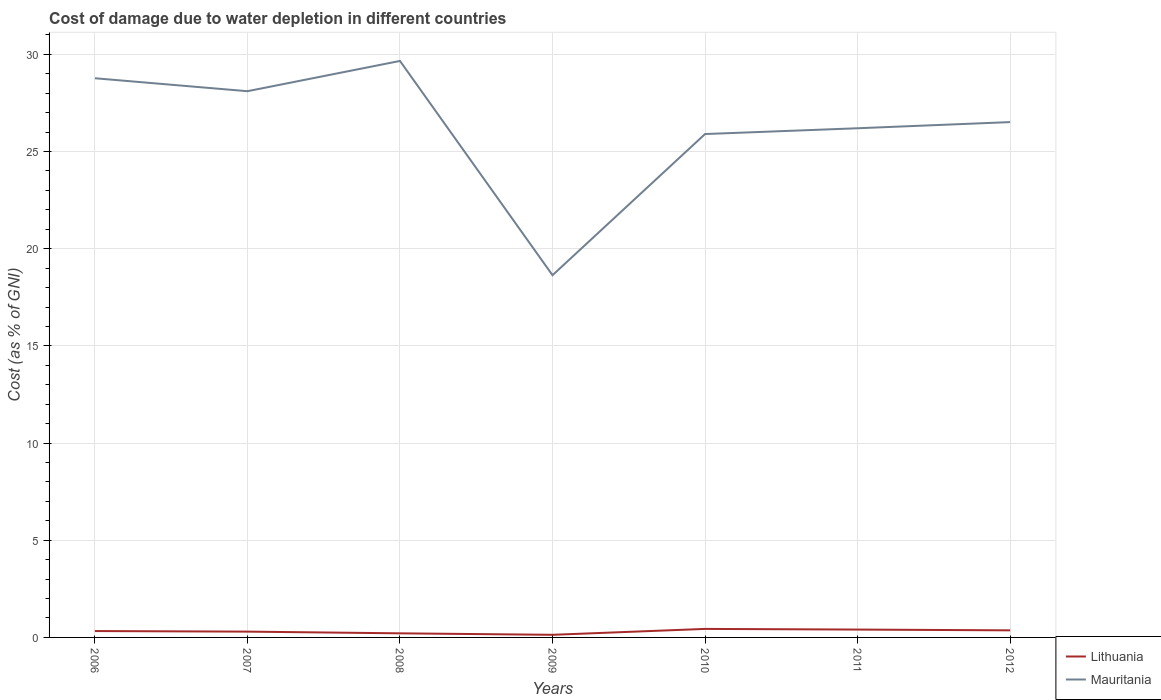How many different coloured lines are there?
Your answer should be compact. 2. Across all years, what is the maximum cost of damage caused due to water depletion in Lithuania?
Keep it short and to the point. 0.13. What is the total cost of damage caused due to water depletion in Mauritania in the graph?
Offer a very short reply. 3.46. What is the difference between the highest and the second highest cost of damage caused due to water depletion in Lithuania?
Provide a short and direct response. 0.3. Is the cost of damage caused due to water depletion in Lithuania strictly greater than the cost of damage caused due to water depletion in Mauritania over the years?
Offer a very short reply. Yes. How many lines are there?
Your answer should be compact. 2. What is the difference between two consecutive major ticks on the Y-axis?
Keep it short and to the point. 5. Are the values on the major ticks of Y-axis written in scientific E-notation?
Offer a terse response. No. Does the graph contain grids?
Your answer should be compact. Yes. Where does the legend appear in the graph?
Your answer should be compact. Bottom right. What is the title of the graph?
Make the answer very short. Cost of damage due to water depletion in different countries. What is the label or title of the Y-axis?
Give a very brief answer. Cost (as % of GNI). What is the Cost (as % of GNI) in Lithuania in 2006?
Offer a very short reply. 0.33. What is the Cost (as % of GNI) in Mauritania in 2006?
Give a very brief answer. 28.77. What is the Cost (as % of GNI) of Lithuania in 2007?
Provide a short and direct response. 0.3. What is the Cost (as % of GNI) of Mauritania in 2007?
Keep it short and to the point. 28.1. What is the Cost (as % of GNI) of Lithuania in 2008?
Offer a terse response. 0.21. What is the Cost (as % of GNI) in Mauritania in 2008?
Offer a terse response. 29.66. What is the Cost (as % of GNI) of Lithuania in 2009?
Your answer should be compact. 0.13. What is the Cost (as % of GNI) of Mauritania in 2009?
Provide a short and direct response. 18.64. What is the Cost (as % of GNI) of Lithuania in 2010?
Provide a succinct answer. 0.44. What is the Cost (as % of GNI) in Mauritania in 2010?
Your answer should be very brief. 25.9. What is the Cost (as % of GNI) of Lithuania in 2011?
Your response must be concise. 0.4. What is the Cost (as % of GNI) of Mauritania in 2011?
Give a very brief answer. 26.2. What is the Cost (as % of GNI) of Lithuania in 2012?
Your answer should be very brief. 0.36. What is the Cost (as % of GNI) of Mauritania in 2012?
Keep it short and to the point. 26.52. Across all years, what is the maximum Cost (as % of GNI) in Lithuania?
Keep it short and to the point. 0.44. Across all years, what is the maximum Cost (as % of GNI) in Mauritania?
Keep it short and to the point. 29.66. Across all years, what is the minimum Cost (as % of GNI) in Lithuania?
Provide a succinct answer. 0.13. Across all years, what is the minimum Cost (as % of GNI) of Mauritania?
Make the answer very short. 18.64. What is the total Cost (as % of GNI) of Lithuania in the graph?
Offer a terse response. 2.18. What is the total Cost (as % of GNI) of Mauritania in the graph?
Provide a succinct answer. 183.79. What is the difference between the Cost (as % of GNI) of Lithuania in 2006 and that in 2007?
Provide a short and direct response. 0.03. What is the difference between the Cost (as % of GNI) of Mauritania in 2006 and that in 2007?
Your answer should be compact. 0.67. What is the difference between the Cost (as % of GNI) of Lithuania in 2006 and that in 2008?
Ensure brevity in your answer.  0.12. What is the difference between the Cost (as % of GNI) of Mauritania in 2006 and that in 2008?
Your response must be concise. -0.89. What is the difference between the Cost (as % of GNI) of Lithuania in 2006 and that in 2009?
Your answer should be compact. 0.19. What is the difference between the Cost (as % of GNI) in Mauritania in 2006 and that in 2009?
Provide a short and direct response. 10.13. What is the difference between the Cost (as % of GNI) of Lithuania in 2006 and that in 2010?
Your answer should be compact. -0.11. What is the difference between the Cost (as % of GNI) of Mauritania in 2006 and that in 2010?
Provide a short and direct response. 2.87. What is the difference between the Cost (as % of GNI) of Lithuania in 2006 and that in 2011?
Your answer should be very brief. -0.08. What is the difference between the Cost (as % of GNI) in Mauritania in 2006 and that in 2011?
Keep it short and to the point. 2.57. What is the difference between the Cost (as % of GNI) in Lithuania in 2006 and that in 2012?
Give a very brief answer. -0.04. What is the difference between the Cost (as % of GNI) of Mauritania in 2006 and that in 2012?
Make the answer very short. 2.26. What is the difference between the Cost (as % of GNI) of Lithuania in 2007 and that in 2008?
Give a very brief answer. 0.09. What is the difference between the Cost (as % of GNI) of Mauritania in 2007 and that in 2008?
Your answer should be very brief. -1.56. What is the difference between the Cost (as % of GNI) in Lithuania in 2007 and that in 2009?
Give a very brief answer. 0.16. What is the difference between the Cost (as % of GNI) of Mauritania in 2007 and that in 2009?
Offer a terse response. 9.47. What is the difference between the Cost (as % of GNI) of Lithuania in 2007 and that in 2010?
Give a very brief answer. -0.14. What is the difference between the Cost (as % of GNI) in Mauritania in 2007 and that in 2010?
Give a very brief answer. 2.2. What is the difference between the Cost (as % of GNI) in Lithuania in 2007 and that in 2011?
Your answer should be compact. -0.11. What is the difference between the Cost (as % of GNI) of Mauritania in 2007 and that in 2011?
Your answer should be very brief. 1.91. What is the difference between the Cost (as % of GNI) in Lithuania in 2007 and that in 2012?
Ensure brevity in your answer.  -0.07. What is the difference between the Cost (as % of GNI) of Mauritania in 2007 and that in 2012?
Your answer should be compact. 1.59. What is the difference between the Cost (as % of GNI) in Lithuania in 2008 and that in 2009?
Your answer should be very brief. 0.08. What is the difference between the Cost (as % of GNI) of Mauritania in 2008 and that in 2009?
Provide a succinct answer. 11.02. What is the difference between the Cost (as % of GNI) of Lithuania in 2008 and that in 2010?
Provide a succinct answer. -0.23. What is the difference between the Cost (as % of GNI) in Mauritania in 2008 and that in 2010?
Keep it short and to the point. 3.76. What is the difference between the Cost (as % of GNI) of Lithuania in 2008 and that in 2011?
Your answer should be very brief. -0.19. What is the difference between the Cost (as % of GNI) in Mauritania in 2008 and that in 2011?
Ensure brevity in your answer.  3.46. What is the difference between the Cost (as % of GNI) of Lithuania in 2008 and that in 2012?
Your answer should be very brief. -0.15. What is the difference between the Cost (as % of GNI) in Mauritania in 2008 and that in 2012?
Your answer should be very brief. 3.15. What is the difference between the Cost (as % of GNI) of Lithuania in 2009 and that in 2010?
Your answer should be compact. -0.3. What is the difference between the Cost (as % of GNI) of Mauritania in 2009 and that in 2010?
Keep it short and to the point. -7.26. What is the difference between the Cost (as % of GNI) in Lithuania in 2009 and that in 2011?
Make the answer very short. -0.27. What is the difference between the Cost (as % of GNI) in Mauritania in 2009 and that in 2011?
Make the answer very short. -7.56. What is the difference between the Cost (as % of GNI) in Lithuania in 2009 and that in 2012?
Provide a succinct answer. -0.23. What is the difference between the Cost (as % of GNI) of Mauritania in 2009 and that in 2012?
Make the answer very short. -7.88. What is the difference between the Cost (as % of GNI) of Lithuania in 2010 and that in 2011?
Your response must be concise. 0.03. What is the difference between the Cost (as % of GNI) of Mauritania in 2010 and that in 2011?
Give a very brief answer. -0.3. What is the difference between the Cost (as % of GNI) of Lithuania in 2010 and that in 2012?
Ensure brevity in your answer.  0.07. What is the difference between the Cost (as % of GNI) in Mauritania in 2010 and that in 2012?
Your answer should be compact. -0.61. What is the difference between the Cost (as % of GNI) in Lithuania in 2011 and that in 2012?
Your response must be concise. 0.04. What is the difference between the Cost (as % of GNI) in Mauritania in 2011 and that in 2012?
Provide a succinct answer. -0.32. What is the difference between the Cost (as % of GNI) of Lithuania in 2006 and the Cost (as % of GNI) of Mauritania in 2007?
Your answer should be compact. -27.78. What is the difference between the Cost (as % of GNI) in Lithuania in 2006 and the Cost (as % of GNI) in Mauritania in 2008?
Give a very brief answer. -29.33. What is the difference between the Cost (as % of GNI) in Lithuania in 2006 and the Cost (as % of GNI) in Mauritania in 2009?
Give a very brief answer. -18.31. What is the difference between the Cost (as % of GNI) of Lithuania in 2006 and the Cost (as % of GNI) of Mauritania in 2010?
Keep it short and to the point. -25.57. What is the difference between the Cost (as % of GNI) of Lithuania in 2006 and the Cost (as % of GNI) of Mauritania in 2011?
Offer a very short reply. -25.87. What is the difference between the Cost (as % of GNI) of Lithuania in 2006 and the Cost (as % of GNI) of Mauritania in 2012?
Ensure brevity in your answer.  -26.19. What is the difference between the Cost (as % of GNI) of Lithuania in 2007 and the Cost (as % of GNI) of Mauritania in 2008?
Your response must be concise. -29.36. What is the difference between the Cost (as % of GNI) of Lithuania in 2007 and the Cost (as % of GNI) of Mauritania in 2009?
Your response must be concise. -18.34. What is the difference between the Cost (as % of GNI) of Lithuania in 2007 and the Cost (as % of GNI) of Mauritania in 2010?
Your response must be concise. -25.6. What is the difference between the Cost (as % of GNI) in Lithuania in 2007 and the Cost (as % of GNI) in Mauritania in 2011?
Offer a very short reply. -25.9. What is the difference between the Cost (as % of GNI) in Lithuania in 2007 and the Cost (as % of GNI) in Mauritania in 2012?
Your answer should be very brief. -26.22. What is the difference between the Cost (as % of GNI) of Lithuania in 2008 and the Cost (as % of GNI) of Mauritania in 2009?
Ensure brevity in your answer.  -18.43. What is the difference between the Cost (as % of GNI) of Lithuania in 2008 and the Cost (as % of GNI) of Mauritania in 2010?
Provide a succinct answer. -25.69. What is the difference between the Cost (as % of GNI) of Lithuania in 2008 and the Cost (as % of GNI) of Mauritania in 2011?
Your answer should be very brief. -25.99. What is the difference between the Cost (as % of GNI) in Lithuania in 2008 and the Cost (as % of GNI) in Mauritania in 2012?
Make the answer very short. -26.3. What is the difference between the Cost (as % of GNI) of Lithuania in 2009 and the Cost (as % of GNI) of Mauritania in 2010?
Provide a short and direct response. -25.77. What is the difference between the Cost (as % of GNI) of Lithuania in 2009 and the Cost (as % of GNI) of Mauritania in 2011?
Offer a very short reply. -26.06. What is the difference between the Cost (as % of GNI) of Lithuania in 2009 and the Cost (as % of GNI) of Mauritania in 2012?
Provide a succinct answer. -26.38. What is the difference between the Cost (as % of GNI) of Lithuania in 2010 and the Cost (as % of GNI) of Mauritania in 2011?
Keep it short and to the point. -25.76. What is the difference between the Cost (as % of GNI) in Lithuania in 2010 and the Cost (as % of GNI) in Mauritania in 2012?
Provide a short and direct response. -26.08. What is the difference between the Cost (as % of GNI) in Lithuania in 2011 and the Cost (as % of GNI) in Mauritania in 2012?
Keep it short and to the point. -26.11. What is the average Cost (as % of GNI) of Lithuania per year?
Keep it short and to the point. 0.31. What is the average Cost (as % of GNI) of Mauritania per year?
Offer a terse response. 26.26. In the year 2006, what is the difference between the Cost (as % of GNI) in Lithuania and Cost (as % of GNI) in Mauritania?
Provide a succinct answer. -28.44. In the year 2007, what is the difference between the Cost (as % of GNI) of Lithuania and Cost (as % of GNI) of Mauritania?
Keep it short and to the point. -27.81. In the year 2008, what is the difference between the Cost (as % of GNI) of Lithuania and Cost (as % of GNI) of Mauritania?
Provide a short and direct response. -29.45. In the year 2009, what is the difference between the Cost (as % of GNI) in Lithuania and Cost (as % of GNI) in Mauritania?
Offer a terse response. -18.5. In the year 2010, what is the difference between the Cost (as % of GNI) of Lithuania and Cost (as % of GNI) of Mauritania?
Your response must be concise. -25.46. In the year 2011, what is the difference between the Cost (as % of GNI) in Lithuania and Cost (as % of GNI) in Mauritania?
Offer a terse response. -25.79. In the year 2012, what is the difference between the Cost (as % of GNI) in Lithuania and Cost (as % of GNI) in Mauritania?
Give a very brief answer. -26.15. What is the ratio of the Cost (as % of GNI) of Lithuania in 2006 to that in 2007?
Your answer should be very brief. 1.1. What is the ratio of the Cost (as % of GNI) of Mauritania in 2006 to that in 2007?
Provide a succinct answer. 1.02. What is the ratio of the Cost (as % of GNI) of Lithuania in 2006 to that in 2008?
Your response must be concise. 1.56. What is the ratio of the Cost (as % of GNI) in Mauritania in 2006 to that in 2008?
Ensure brevity in your answer.  0.97. What is the ratio of the Cost (as % of GNI) of Lithuania in 2006 to that in 2009?
Make the answer very short. 2.44. What is the ratio of the Cost (as % of GNI) in Mauritania in 2006 to that in 2009?
Provide a short and direct response. 1.54. What is the ratio of the Cost (as % of GNI) of Lithuania in 2006 to that in 2010?
Make the answer very short. 0.75. What is the ratio of the Cost (as % of GNI) in Mauritania in 2006 to that in 2010?
Your answer should be compact. 1.11. What is the ratio of the Cost (as % of GNI) of Lithuania in 2006 to that in 2011?
Give a very brief answer. 0.81. What is the ratio of the Cost (as % of GNI) of Mauritania in 2006 to that in 2011?
Offer a very short reply. 1.1. What is the ratio of the Cost (as % of GNI) of Lithuania in 2006 to that in 2012?
Your response must be concise. 0.9. What is the ratio of the Cost (as % of GNI) of Mauritania in 2006 to that in 2012?
Your answer should be very brief. 1.09. What is the ratio of the Cost (as % of GNI) in Lithuania in 2007 to that in 2008?
Your response must be concise. 1.42. What is the ratio of the Cost (as % of GNI) in Mauritania in 2007 to that in 2008?
Give a very brief answer. 0.95. What is the ratio of the Cost (as % of GNI) in Lithuania in 2007 to that in 2009?
Your answer should be compact. 2.21. What is the ratio of the Cost (as % of GNI) in Mauritania in 2007 to that in 2009?
Provide a succinct answer. 1.51. What is the ratio of the Cost (as % of GNI) of Lithuania in 2007 to that in 2010?
Ensure brevity in your answer.  0.68. What is the ratio of the Cost (as % of GNI) in Mauritania in 2007 to that in 2010?
Offer a very short reply. 1.09. What is the ratio of the Cost (as % of GNI) in Lithuania in 2007 to that in 2011?
Your answer should be compact. 0.74. What is the ratio of the Cost (as % of GNI) in Mauritania in 2007 to that in 2011?
Provide a short and direct response. 1.07. What is the ratio of the Cost (as % of GNI) in Lithuania in 2007 to that in 2012?
Offer a very short reply. 0.82. What is the ratio of the Cost (as % of GNI) of Mauritania in 2007 to that in 2012?
Your answer should be very brief. 1.06. What is the ratio of the Cost (as % of GNI) in Lithuania in 2008 to that in 2009?
Provide a succinct answer. 1.56. What is the ratio of the Cost (as % of GNI) in Mauritania in 2008 to that in 2009?
Keep it short and to the point. 1.59. What is the ratio of the Cost (as % of GNI) of Lithuania in 2008 to that in 2010?
Provide a short and direct response. 0.48. What is the ratio of the Cost (as % of GNI) of Mauritania in 2008 to that in 2010?
Your answer should be very brief. 1.15. What is the ratio of the Cost (as % of GNI) of Lithuania in 2008 to that in 2011?
Your response must be concise. 0.52. What is the ratio of the Cost (as % of GNI) in Mauritania in 2008 to that in 2011?
Your answer should be compact. 1.13. What is the ratio of the Cost (as % of GNI) of Lithuania in 2008 to that in 2012?
Your answer should be compact. 0.58. What is the ratio of the Cost (as % of GNI) in Mauritania in 2008 to that in 2012?
Provide a succinct answer. 1.12. What is the ratio of the Cost (as % of GNI) in Lithuania in 2009 to that in 2010?
Offer a terse response. 0.31. What is the ratio of the Cost (as % of GNI) in Mauritania in 2009 to that in 2010?
Your answer should be compact. 0.72. What is the ratio of the Cost (as % of GNI) in Lithuania in 2009 to that in 2011?
Offer a terse response. 0.33. What is the ratio of the Cost (as % of GNI) in Mauritania in 2009 to that in 2011?
Offer a very short reply. 0.71. What is the ratio of the Cost (as % of GNI) in Lithuania in 2009 to that in 2012?
Your answer should be very brief. 0.37. What is the ratio of the Cost (as % of GNI) of Mauritania in 2009 to that in 2012?
Your answer should be very brief. 0.7. What is the ratio of the Cost (as % of GNI) in Mauritania in 2010 to that in 2011?
Your response must be concise. 0.99. What is the ratio of the Cost (as % of GNI) in Lithuania in 2010 to that in 2012?
Offer a very short reply. 1.2. What is the ratio of the Cost (as % of GNI) of Mauritania in 2010 to that in 2012?
Ensure brevity in your answer.  0.98. What is the ratio of the Cost (as % of GNI) of Lithuania in 2011 to that in 2012?
Ensure brevity in your answer.  1.11. What is the ratio of the Cost (as % of GNI) of Mauritania in 2011 to that in 2012?
Your answer should be very brief. 0.99. What is the difference between the highest and the second highest Cost (as % of GNI) in Lithuania?
Your answer should be very brief. 0.03. What is the difference between the highest and the second highest Cost (as % of GNI) of Mauritania?
Keep it short and to the point. 0.89. What is the difference between the highest and the lowest Cost (as % of GNI) in Lithuania?
Offer a terse response. 0.3. What is the difference between the highest and the lowest Cost (as % of GNI) of Mauritania?
Provide a succinct answer. 11.02. 